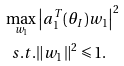<formula> <loc_0><loc_0><loc_500><loc_500>\max _ { w _ { 1 } } & \left | a _ { 1 } ^ { T } ( \theta _ { I } ) w _ { 1 } \right | ^ { 2 } \\ s . t . & \| w _ { 1 } \| ^ { 2 } \leqslant 1 .</formula> 